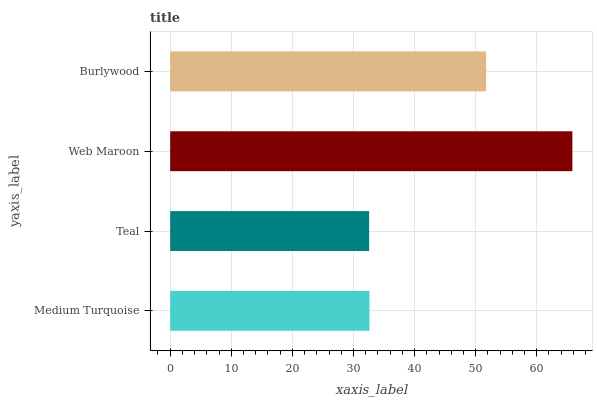Is Teal the minimum?
Answer yes or no. Yes. Is Web Maroon the maximum?
Answer yes or no. Yes. Is Web Maroon the minimum?
Answer yes or no. No. Is Teal the maximum?
Answer yes or no. No. Is Web Maroon greater than Teal?
Answer yes or no. Yes. Is Teal less than Web Maroon?
Answer yes or no. Yes. Is Teal greater than Web Maroon?
Answer yes or no. No. Is Web Maroon less than Teal?
Answer yes or no. No. Is Burlywood the high median?
Answer yes or no. Yes. Is Medium Turquoise the low median?
Answer yes or no. Yes. Is Web Maroon the high median?
Answer yes or no. No. Is Teal the low median?
Answer yes or no. No. 